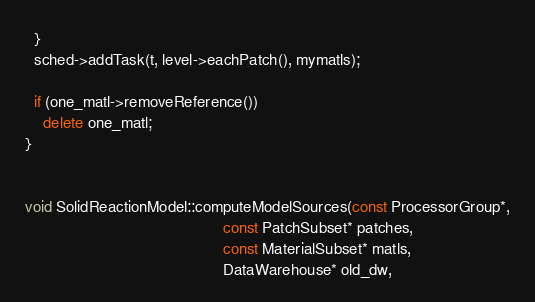<code> <loc_0><loc_0><loc_500><loc_500><_C++_>  }
  sched->addTask(t, level->eachPatch(), mymatls);

  if (one_matl->removeReference())
    delete one_matl;
}


void SolidReactionModel::computeModelSources(const ProcessorGroup*,
                                             const PatchSubset* patches,
                                             const MaterialSubset* matls,
                                             DataWarehouse* old_dw,</code> 